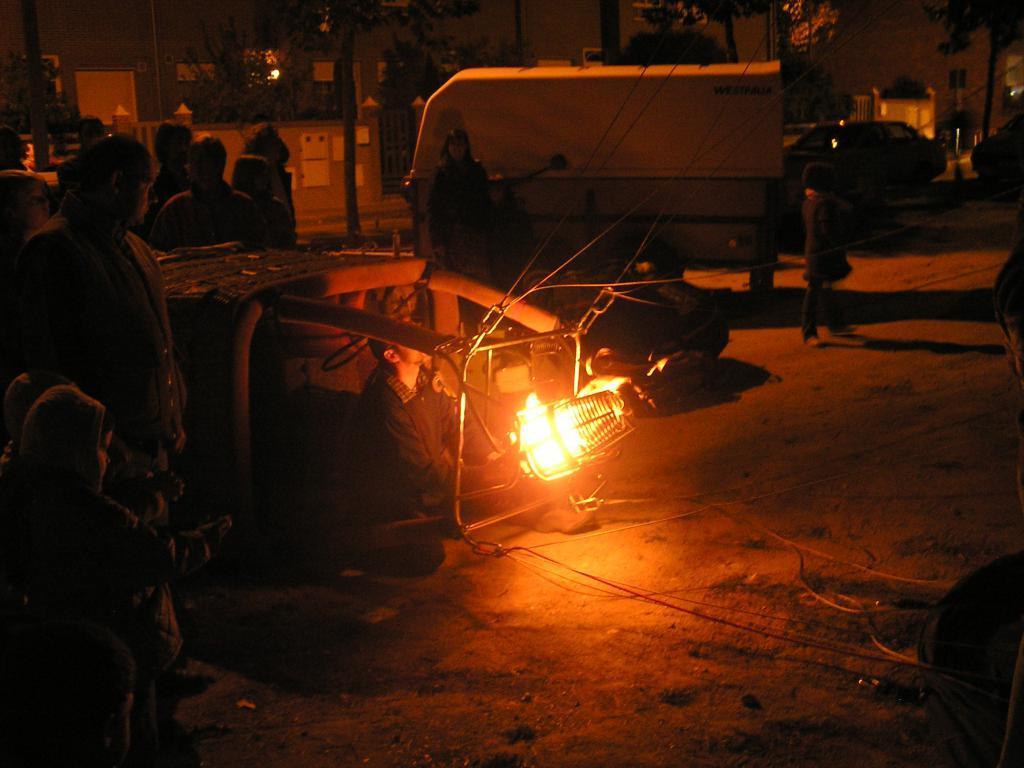Please provide a concise description of this image. In this picture we can see some people are standing, there is a person sitting in the middle, in the background there are some trees, a house and a car, we can also a light in the middle. 